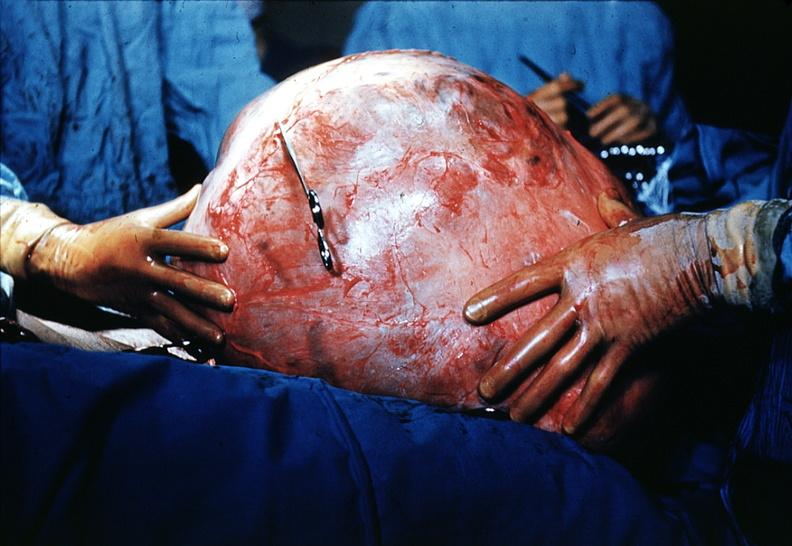s mucinous cystadenocarcinoma present?
Answer the question using a single word or phrase. Yes 